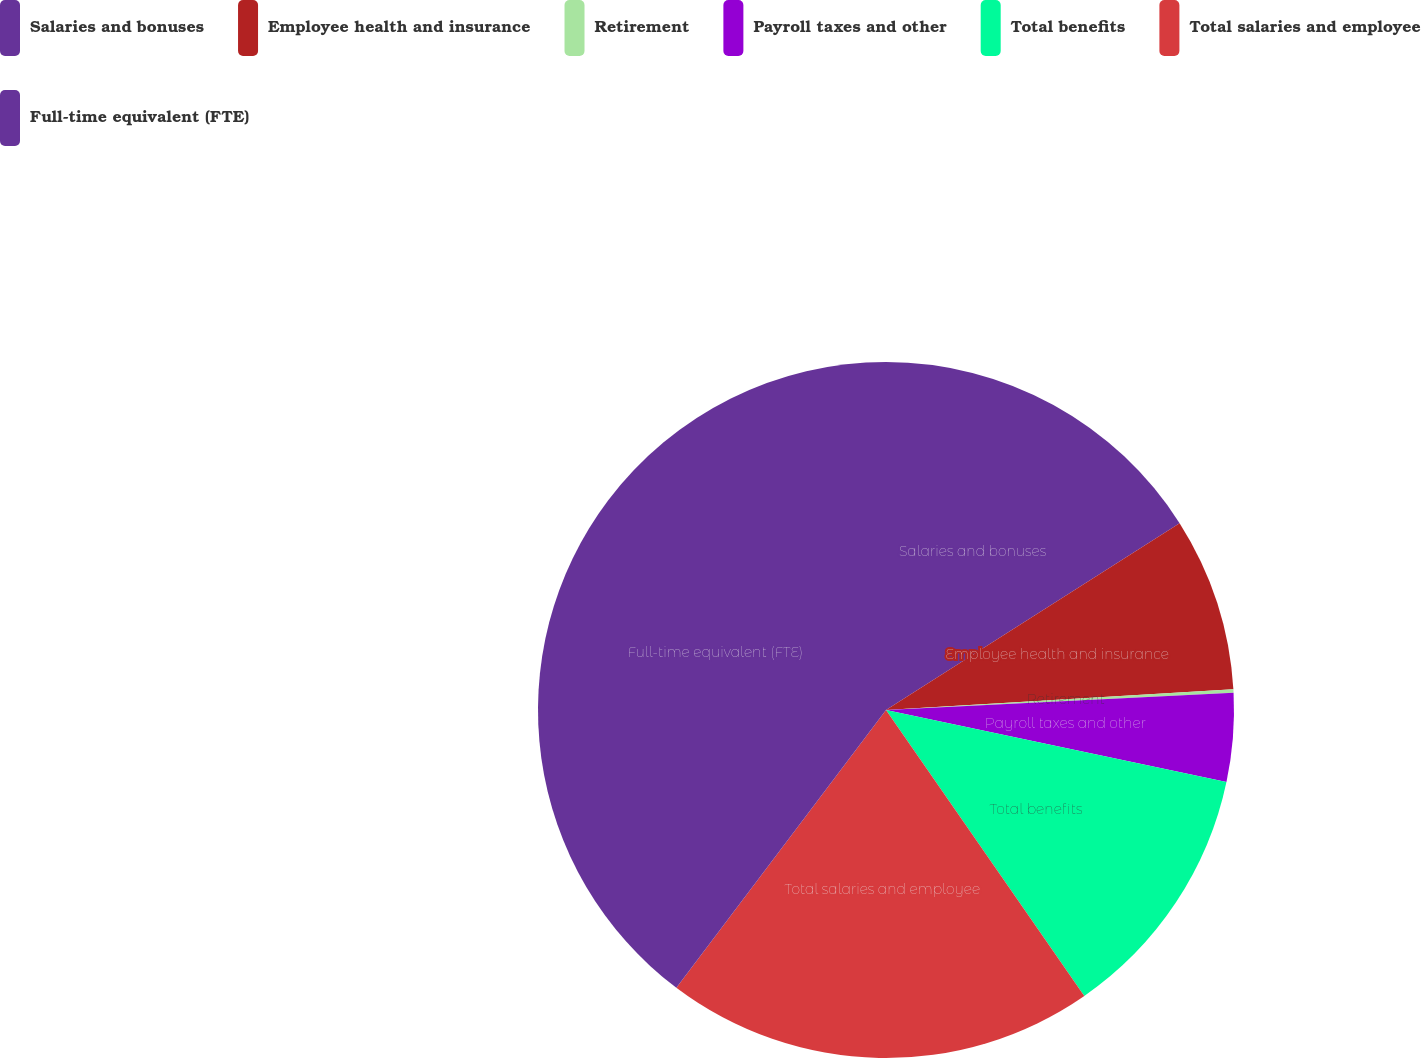Convert chart. <chart><loc_0><loc_0><loc_500><loc_500><pie_chart><fcel>Salaries and bonuses<fcel>Employee health and insurance<fcel>Retirement<fcel>Payroll taxes and other<fcel>Total benefits<fcel>Total salaries and employee<fcel>Full-time equivalent (FTE)<nl><fcel>15.98%<fcel>8.07%<fcel>0.16%<fcel>4.11%<fcel>12.03%<fcel>19.94%<fcel>39.71%<nl></chart> 